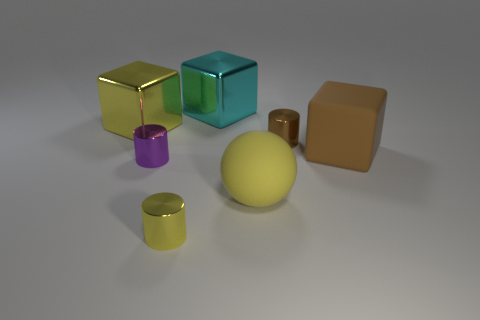What size is the cube that is on the right side of the brown thing to the left of the big brown object?
Your answer should be compact. Large. Are any big green cylinders visible?
Provide a short and direct response. No. The thing that is both on the left side of the ball and in front of the tiny purple cylinder is made of what material?
Your response must be concise. Metal. Is the number of small objects behind the small yellow metallic cylinder greater than the number of big cyan shiny things that are behind the large yellow shiny object?
Your response must be concise. Yes. Is there a brown shiny cylinder that has the same size as the brown cube?
Your answer should be very brief. No. There is a yellow thing that is right of the cyan cube that is behind the big yellow rubber object that is in front of the purple metallic object; what size is it?
Keep it short and to the point. Large. The big sphere has what color?
Your answer should be very brief. Yellow. Is the number of blocks left of the cyan thing greater than the number of gray metallic blocks?
Provide a short and direct response. Yes. There is a purple metal cylinder; what number of tiny cylinders are to the right of it?
Your answer should be very brief. 2. There is a large shiny object that is the same color as the ball; what is its shape?
Keep it short and to the point. Cube. 